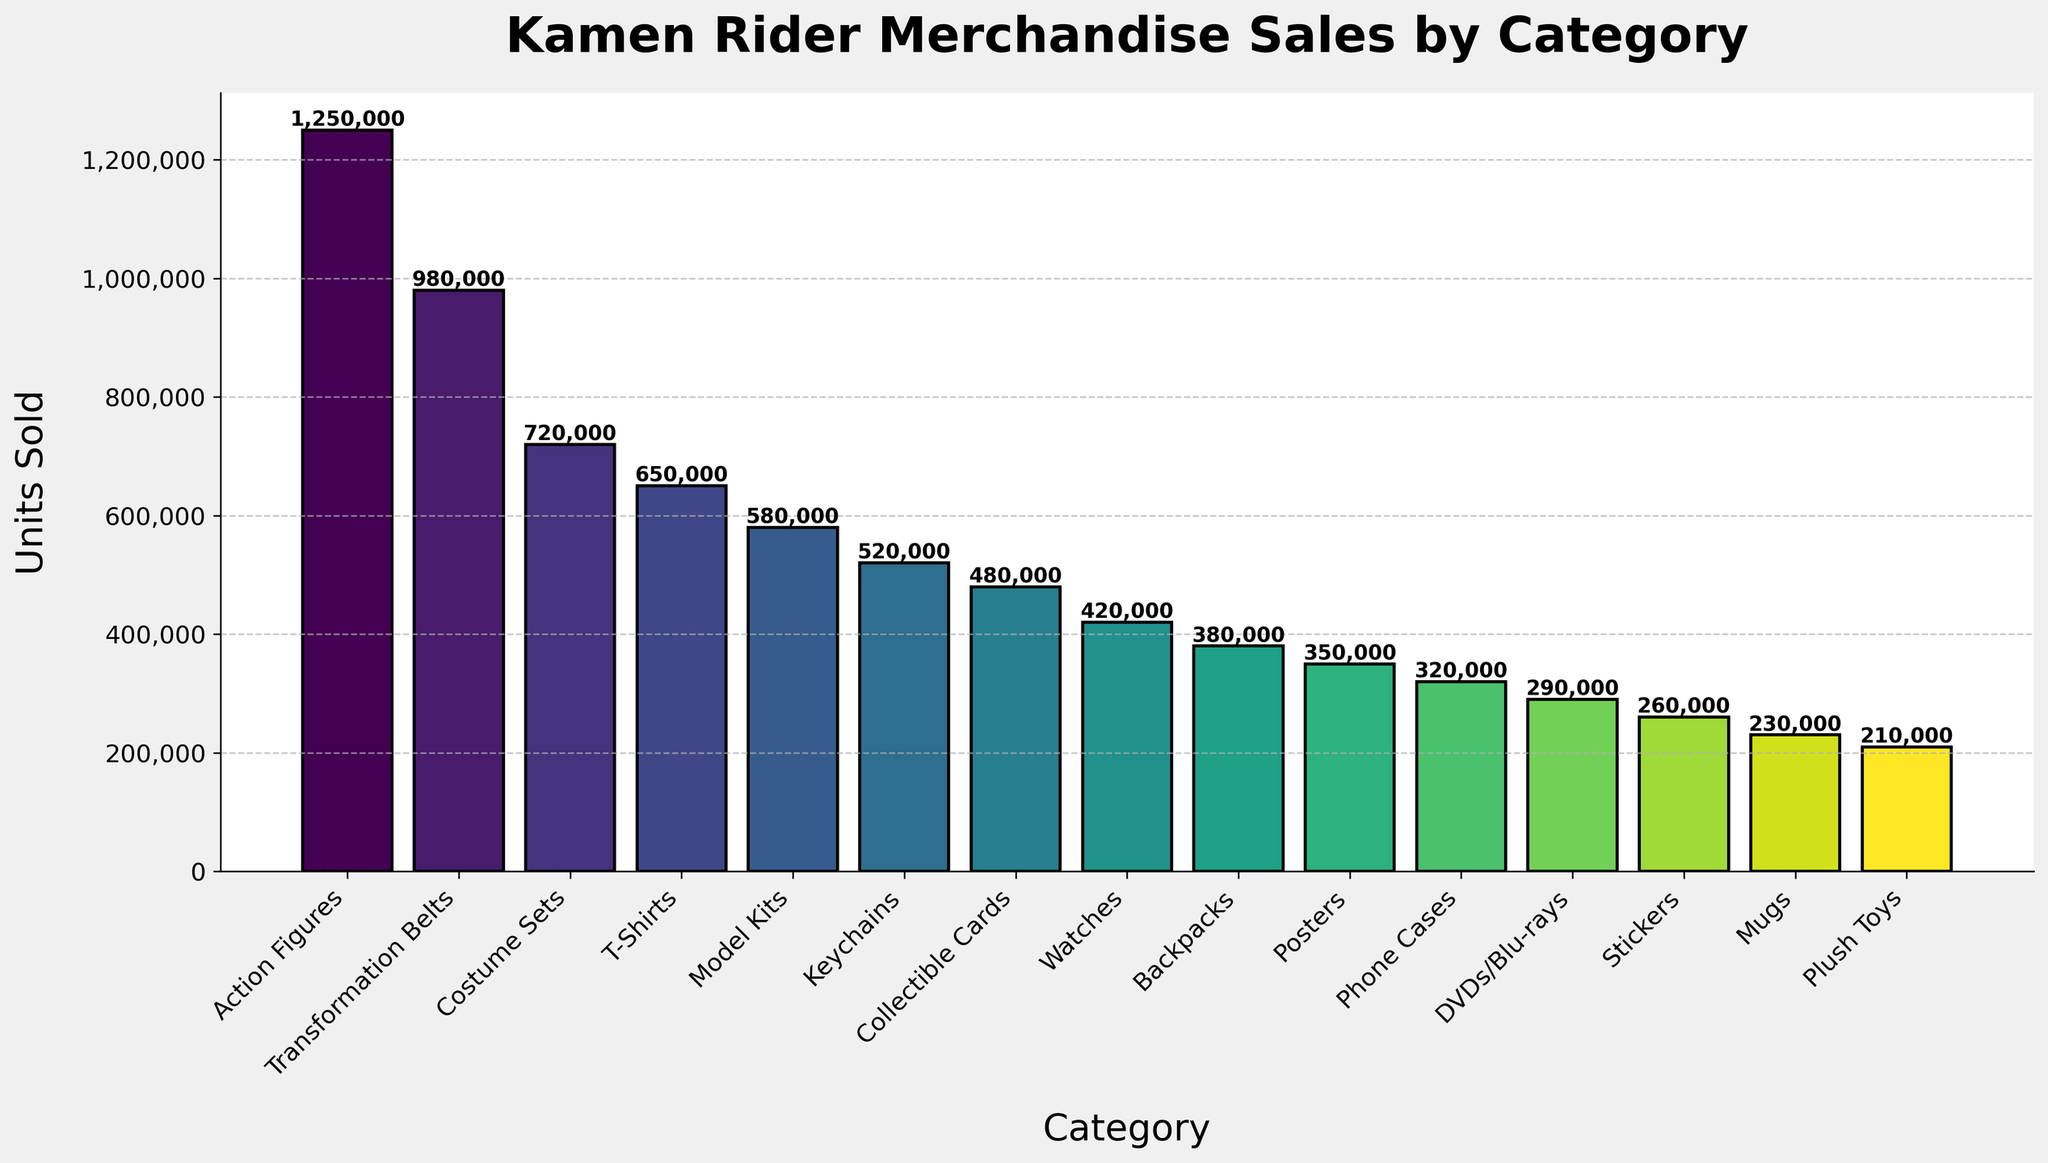What's the most sold category of Kamen Rider merchandise? The height of the bars represents the units sold. The bar for "Action Figures" is the tallest, indicating that it is the most sold category.
Answer: Action Figures How many more units of Transformation Belts were sold compared to Posters? Subtract the units sold of Posters (350,000) from Transformation Belts (980,000). Calculating this: 980,000 - 350,000 = 630,000.
Answer: 630,000 Which category sold the least number of units? The smallest bar corresponds to the "Plush Toys" category.
Answer: Plush Toys Compare the total units sold for T-Shirts, Keychains, and DVDs/Blu-rays combined to Action Figures alone. Which is higher? Sum the units sold for T-Shirts (650,000), Keychains (520,000), and DVDs/Blu-rays (290,000), which equals 1,460,000. Compare this to Action Figures (1,250,000). The combination is higher.
Answer: Combination of T-Shirts, Keychains, and DVDs/Blu-rays What is the difference in units sold between the highest and lowest selling categories? The highest is "Action Figures" (1,250,000) and the lowest is "Plush Toys" (210,000). Calculate the difference: 1,250,000 - 210,000 = 1,040,000.
Answer: 1,040,000 Which category had more sales: Model Kits or Backpacks, and by how much? Compare Model Kits (580,000) and Backpacks (380,000). Model Kits sold 200,000 more units.
Answer: Model Kits by 200,000 Is the amount of units sold for Keychains closer to that of Posters or T-Shirts? Keychains sold (520,000), Posters (350,000), and T-Shirts (650,000). The difference with Posters: 520,000 - 350,000 = 170,000. The difference with T-Shirts: 650,000 - 520,000 = 130,000. It is closer to T-Shirts.
Answer: T-Shirts What is the combined total of units sold for the categories that sold less than 500,000 units? The relevant categories are Collectible Cards (480,000), Watches (420,000), Backpacks (380,000), Posters (350,000), Phone Cases (320,000), DVDs/Blu-rays (290,000), Stickers (260,000), Mugs (230,000), and Plush Toys (210,000). Sum them all: 480,000 + 420,000 + 380,000 + 350,000 + 320,000 + 290,000 + 260,000 + 230,000 + 210,000 = 2,940,000.
Answer: 2,940,000 